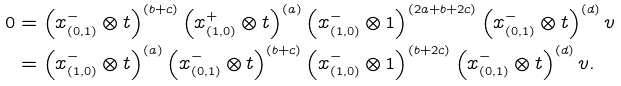Convert formula to latex. <formula><loc_0><loc_0><loc_500><loc_500>0 & = \left ( x ^ { - } _ { ( 0 , 1 ) } \otimes t \right ) ^ { ( b + c ) } \left ( x ^ { + } _ { ( 1 , 0 ) } \otimes t \right ) ^ { ( a ) } \left ( x ^ { - } _ { ( 1 , 0 ) } \otimes 1 \right ) ^ { ( 2 a + b + 2 c ) } \left ( x ^ { - } _ { ( 0 , 1 ) } \otimes t \right ) ^ { ( d ) } v & \\ & = \left ( x ^ { - } _ { ( 1 , 0 ) } \otimes t \right ) ^ { ( a ) } \left ( x ^ { - } _ { ( 0 , 1 ) } \otimes t \right ) ^ { ( b + c ) } \left ( x ^ { - } _ { ( 1 , 0 ) } \otimes 1 \right ) ^ { ( b + 2 c ) } \left ( x ^ { - } _ { ( 0 , 1 ) } \otimes t \right ) ^ { ( d ) } v .</formula> 